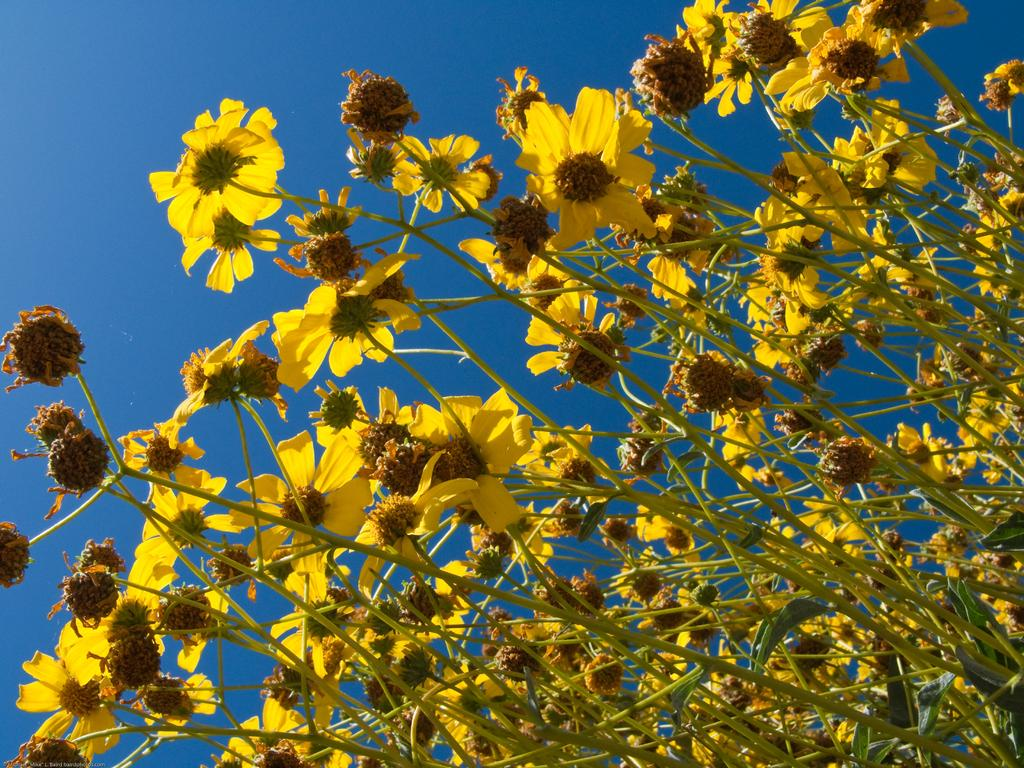What type of flowers can be seen in the image? There are yellow flowers in the image. What part of the flowers are connected to the ground? The flowers have stems that connect them to the ground. What is visible in the background of the image? The sky is visible in the image. What color is the sky in the image? The sky is blue in the image. Can you see a skateboard being used by someone in the image? There is no skateboard or person using one in the image. Is there a chain connecting the flowers in the image? There is no chain connecting the flowers in the image; they are separate entities. 